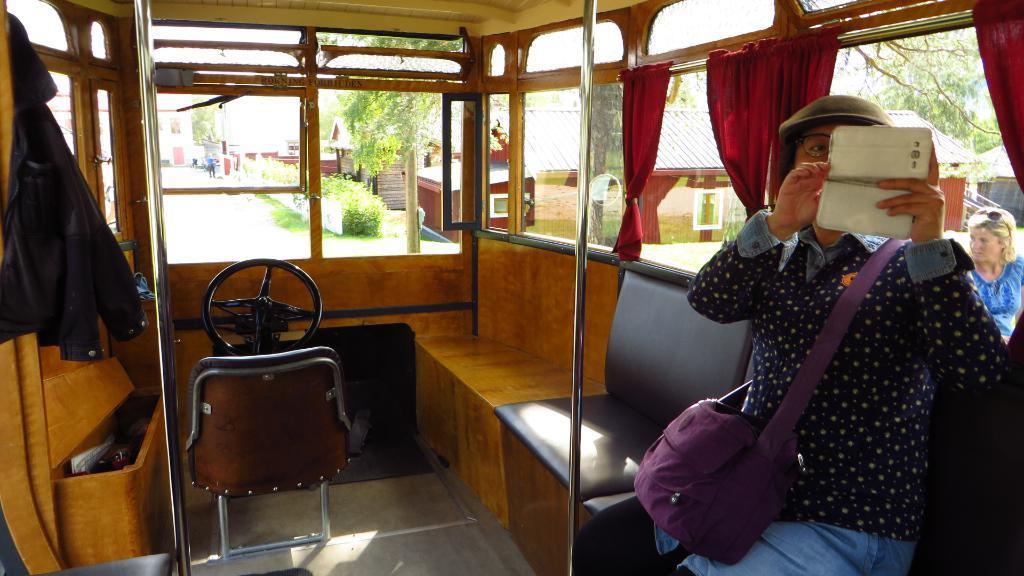In one or two sentences, can you explain what this image depicts? This is an inside view of a vehicle. On the right side, I can see a person is sitting on the chair. The person is holding a mobile in the hands and looking into the mobile. On the left side, I can see a jacket. In the middle of the image there is a chair which is placed on the floor. At the back of it I can see the steering. There are few windows and curtains. Through the windows we can see the outside view. In the outside, I can see the plants, trees and houses and also the road. 